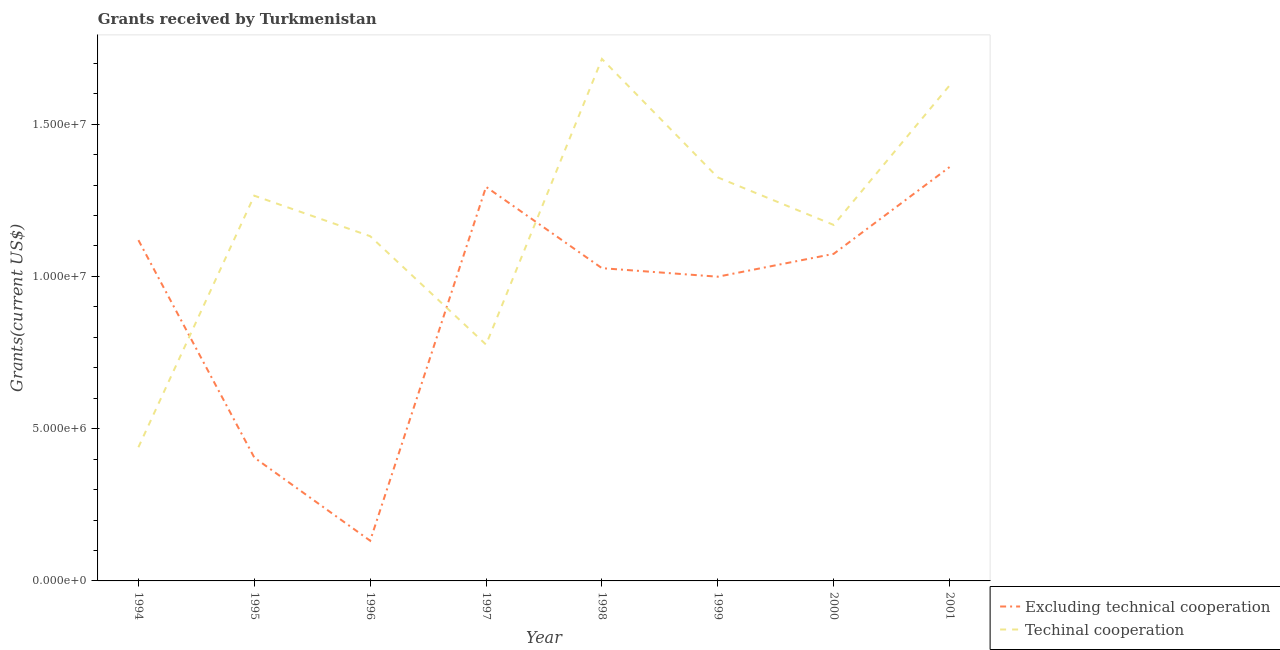How many different coloured lines are there?
Your answer should be very brief. 2. Does the line corresponding to amount of grants received(excluding technical cooperation) intersect with the line corresponding to amount of grants received(including technical cooperation)?
Your response must be concise. Yes. What is the amount of grants received(including technical cooperation) in 2000?
Give a very brief answer. 1.17e+07. Across all years, what is the maximum amount of grants received(including technical cooperation)?
Offer a very short reply. 1.71e+07. Across all years, what is the minimum amount of grants received(including technical cooperation)?
Provide a short and direct response. 4.39e+06. In which year was the amount of grants received(including technical cooperation) maximum?
Provide a short and direct response. 1998. What is the total amount of grants received(including technical cooperation) in the graph?
Keep it short and to the point. 9.45e+07. What is the difference between the amount of grants received(excluding technical cooperation) in 1996 and that in 1999?
Offer a very short reply. -8.67e+06. What is the difference between the amount of grants received(including technical cooperation) in 1997 and the amount of grants received(excluding technical cooperation) in 1995?
Your answer should be very brief. 3.71e+06. What is the average amount of grants received(including technical cooperation) per year?
Give a very brief answer. 1.18e+07. In the year 1998, what is the difference between the amount of grants received(including technical cooperation) and amount of grants received(excluding technical cooperation)?
Your answer should be very brief. 6.87e+06. In how many years, is the amount of grants received(including technical cooperation) greater than 13000000 US$?
Your answer should be compact. 3. What is the ratio of the amount of grants received(excluding technical cooperation) in 1998 to that in 2001?
Your response must be concise. 0.76. Is the difference between the amount of grants received(excluding technical cooperation) in 1994 and 2001 greater than the difference between the amount of grants received(including technical cooperation) in 1994 and 2001?
Your answer should be very brief. Yes. What is the difference between the highest and the second highest amount of grants received(excluding technical cooperation)?
Offer a very short reply. 6.50e+05. What is the difference between the highest and the lowest amount of grants received(excluding technical cooperation)?
Provide a succinct answer. 1.23e+07. Is the amount of grants received(excluding technical cooperation) strictly greater than the amount of grants received(including technical cooperation) over the years?
Ensure brevity in your answer.  No. Is the amount of grants received(including technical cooperation) strictly less than the amount of grants received(excluding technical cooperation) over the years?
Provide a succinct answer. No. Does the graph contain grids?
Offer a terse response. No. How are the legend labels stacked?
Your answer should be very brief. Vertical. What is the title of the graph?
Make the answer very short. Grants received by Turkmenistan. What is the label or title of the Y-axis?
Offer a terse response. Grants(current US$). What is the Grants(current US$) of Excluding technical cooperation in 1994?
Give a very brief answer. 1.12e+07. What is the Grants(current US$) of Techinal cooperation in 1994?
Your answer should be compact. 4.39e+06. What is the Grants(current US$) of Excluding technical cooperation in 1995?
Give a very brief answer. 4.05e+06. What is the Grants(current US$) in Techinal cooperation in 1995?
Ensure brevity in your answer.  1.26e+07. What is the Grants(current US$) in Excluding technical cooperation in 1996?
Your answer should be very brief. 1.32e+06. What is the Grants(current US$) in Techinal cooperation in 1996?
Offer a terse response. 1.13e+07. What is the Grants(current US$) in Excluding technical cooperation in 1997?
Make the answer very short. 1.29e+07. What is the Grants(current US$) in Techinal cooperation in 1997?
Make the answer very short. 7.76e+06. What is the Grants(current US$) of Excluding technical cooperation in 1998?
Your answer should be very brief. 1.03e+07. What is the Grants(current US$) of Techinal cooperation in 1998?
Give a very brief answer. 1.71e+07. What is the Grants(current US$) of Excluding technical cooperation in 1999?
Provide a succinct answer. 9.99e+06. What is the Grants(current US$) in Techinal cooperation in 1999?
Offer a terse response. 1.32e+07. What is the Grants(current US$) in Excluding technical cooperation in 2000?
Keep it short and to the point. 1.07e+07. What is the Grants(current US$) in Techinal cooperation in 2000?
Provide a short and direct response. 1.17e+07. What is the Grants(current US$) in Excluding technical cooperation in 2001?
Your response must be concise. 1.36e+07. What is the Grants(current US$) of Techinal cooperation in 2001?
Offer a terse response. 1.63e+07. Across all years, what is the maximum Grants(current US$) of Excluding technical cooperation?
Make the answer very short. 1.36e+07. Across all years, what is the maximum Grants(current US$) of Techinal cooperation?
Your answer should be compact. 1.71e+07. Across all years, what is the minimum Grants(current US$) of Excluding technical cooperation?
Make the answer very short. 1.32e+06. Across all years, what is the minimum Grants(current US$) in Techinal cooperation?
Provide a short and direct response. 4.39e+06. What is the total Grants(current US$) of Excluding technical cooperation in the graph?
Make the answer very short. 7.41e+07. What is the total Grants(current US$) of Techinal cooperation in the graph?
Your response must be concise. 9.45e+07. What is the difference between the Grants(current US$) of Excluding technical cooperation in 1994 and that in 1995?
Give a very brief answer. 7.14e+06. What is the difference between the Grants(current US$) of Techinal cooperation in 1994 and that in 1995?
Your answer should be very brief. -8.26e+06. What is the difference between the Grants(current US$) in Excluding technical cooperation in 1994 and that in 1996?
Make the answer very short. 9.87e+06. What is the difference between the Grants(current US$) of Techinal cooperation in 1994 and that in 1996?
Your response must be concise. -6.93e+06. What is the difference between the Grants(current US$) in Excluding technical cooperation in 1994 and that in 1997?
Ensure brevity in your answer.  -1.75e+06. What is the difference between the Grants(current US$) in Techinal cooperation in 1994 and that in 1997?
Provide a succinct answer. -3.37e+06. What is the difference between the Grants(current US$) of Excluding technical cooperation in 1994 and that in 1998?
Your answer should be compact. 9.20e+05. What is the difference between the Grants(current US$) of Techinal cooperation in 1994 and that in 1998?
Provide a short and direct response. -1.28e+07. What is the difference between the Grants(current US$) of Excluding technical cooperation in 1994 and that in 1999?
Keep it short and to the point. 1.20e+06. What is the difference between the Grants(current US$) in Techinal cooperation in 1994 and that in 1999?
Keep it short and to the point. -8.86e+06. What is the difference between the Grants(current US$) of Excluding technical cooperation in 1994 and that in 2000?
Make the answer very short. 4.50e+05. What is the difference between the Grants(current US$) in Techinal cooperation in 1994 and that in 2000?
Provide a short and direct response. -7.30e+06. What is the difference between the Grants(current US$) of Excluding technical cooperation in 1994 and that in 2001?
Offer a terse response. -2.40e+06. What is the difference between the Grants(current US$) in Techinal cooperation in 1994 and that in 2001?
Your answer should be very brief. -1.19e+07. What is the difference between the Grants(current US$) in Excluding technical cooperation in 1995 and that in 1996?
Your answer should be very brief. 2.73e+06. What is the difference between the Grants(current US$) in Techinal cooperation in 1995 and that in 1996?
Give a very brief answer. 1.33e+06. What is the difference between the Grants(current US$) in Excluding technical cooperation in 1995 and that in 1997?
Your answer should be compact. -8.89e+06. What is the difference between the Grants(current US$) of Techinal cooperation in 1995 and that in 1997?
Provide a short and direct response. 4.89e+06. What is the difference between the Grants(current US$) in Excluding technical cooperation in 1995 and that in 1998?
Give a very brief answer. -6.22e+06. What is the difference between the Grants(current US$) in Techinal cooperation in 1995 and that in 1998?
Provide a succinct answer. -4.49e+06. What is the difference between the Grants(current US$) in Excluding technical cooperation in 1995 and that in 1999?
Provide a succinct answer. -5.94e+06. What is the difference between the Grants(current US$) in Techinal cooperation in 1995 and that in 1999?
Provide a succinct answer. -6.00e+05. What is the difference between the Grants(current US$) of Excluding technical cooperation in 1995 and that in 2000?
Provide a short and direct response. -6.69e+06. What is the difference between the Grants(current US$) in Techinal cooperation in 1995 and that in 2000?
Ensure brevity in your answer.  9.60e+05. What is the difference between the Grants(current US$) of Excluding technical cooperation in 1995 and that in 2001?
Your answer should be compact. -9.54e+06. What is the difference between the Grants(current US$) of Techinal cooperation in 1995 and that in 2001?
Provide a succinct answer. -3.62e+06. What is the difference between the Grants(current US$) of Excluding technical cooperation in 1996 and that in 1997?
Your response must be concise. -1.16e+07. What is the difference between the Grants(current US$) of Techinal cooperation in 1996 and that in 1997?
Provide a short and direct response. 3.56e+06. What is the difference between the Grants(current US$) in Excluding technical cooperation in 1996 and that in 1998?
Make the answer very short. -8.95e+06. What is the difference between the Grants(current US$) in Techinal cooperation in 1996 and that in 1998?
Offer a terse response. -5.82e+06. What is the difference between the Grants(current US$) of Excluding technical cooperation in 1996 and that in 1999?
Give a very brief answer. -8.67e+06. What is the difference between the Grants(current US$) in Techinal cooperation in 1996 and that in 1999?
Keep it short and to the point. -1.93e+06. What is the difference between the Grants(current US$) in Excluding technical cooperation in 1996 and that in 2000?
Make the answer very short. -9.42e+06. What is the difference between the Grants(current US$) in Techinal cooperation in 1996 and that in 2000?
Keep it short and to the point. -3.70e+05. What is the difference between the Grants(current US$) in Excluding technical cooperation in 1996 and that in 2001?
Ensure brevity in your answer.  -1.23e+07. What is the difference between the Grants(current US$) of Techinal cooperation in 1996 and that in 2001?
Keep it short and to the point. -4.95e+06. What is the difference between the Grants(current US$) of Excluding technical cooperation in 1997 and that in 1998?
Give a very brief answer. 2.67e+06. What is the difference between the Grants(current US$) in Techinal cooperation in 1997 and that in 1998?
Ensure brevity in your answer.  -9.38e+06. What is the difference between the Grants(current US$) of Excluding technical cooperation in 1997 and that in 1999?
Offer a very short reply. 2.95e+06. What is the difference between the Grants(current US$) in Techinal cooperation in 1997 and that in 1999?
Provide a succinct answer. -5.49e+06. What is the difference between the Grants(current US$) of Excluding technical cooperation in 1997 and that in 2000?
Offer a very short reply. 2.20e+06. What is the difference between the Grants(current US$) of Techinal cooperation in 1997 and that in 2000?
Your answer should be very brief. -3.93e+06. What is the difference between the Grants(current US$) of Excluding technical cooperation in 1997 and that in 2001?
Your answer should be compact. -6.50e+05. What is the difference between the Grants(current US$) of Techinal cooperation in 1997 and that in 2001?
Keep it short and to the point. -8.51e+06. What is the difference between the Grants(current US$) in Techinal cooperation in 1998 and that in 1999?
Offer a terse response. 3.89e+06. What is the difference between the Grants(current US$) in Excluding technical cooperation in 1998 and that in 2000?
Your answer should be very brief. -4.70e+05. What is the difference between the Grants(current US$) in Techinal cooperation in 1998 and that in 2000?
Your response must be concise. 5.45e+06. What is the difference between the Grants(current US$) of Excluding technical cooperation in 1998 and that in 2001?
Give a very brief answer. -3.32e+06. What is the difference between the Grants(current US$) in Techinal cooperation in 1998 and that in 2001?
Make the answer very short. 8.70e+05. What is the difference between the Grants(current US$) in Excluding technical cooperation in 1999 and that in 2000?
Keep it short and to the point. -7.50e+05. What is the difference between the Grants(current US$) in Techinal cooperation in 1999 and that in 2000?
Ensure brevity in your answer.  1.56e+06. What is the difference between the Grants(current US$) in Excluding technical cooperation in 1999 and that in 2001?
Your response must be concise. -3.60e+06. What is the difference between the Grants(current US$) of Techinal cooperation in 1999 and that in 2001?
Your answer should be compact. -3.02e+06. What is the difference between the Grants(current US$) in Excluding technical cooperation in 2000 and that in 2001?
Make the answer very short. -2.85e+06. What is the difference between the Grants(current US$) in Techinal cooperation in 2000 and that in 2001?
Offer a terse response. -4.58e+06. What is the difference between the Grants(current US$) of Excluding technical cooperation in 1994 and the Grants(current US$) of Techinal cooperation in 1995?
Provide a short and direct response. -1.46e+06. What is the difference between the Grants(current US$) of Excluding technical cooperation in 1994 and the Grants(current US$) of Techinal cooperation in 1997?
Your answer should be very brief. 3.43e+06. What is the difference between the Grants(current US$) in Excluding technical cooperation in 1994 and the Grants(current US$) in Techinal cooperation in 1998?
Your answer should be compact. -5.95e+06. What is the difference between the Grants(current US$) of Excluding technical cooperation in 1994 and the Grants(current US$) of Techinal cooperation in 1999?
Ensure brevity in your answer.  -2.06e+06. What is the difference between the Grants(current US$) in Excluding technical cooperation in 1994 and the Grants(current US$) in Techinal cooperation in 2000?
Your answer should be compact. -5.00e+05. What is the difference between the Grants(current US$) of Excluding technical cooperation in 1994 and the Grants(current US$) of Techinal cooperation in 2001?
Provide a succinct answer. -5.08e+06. What is the difference between the Grants(current US$) of Excluding technical cooperation in 1995 and the Grants(current US$) of Techinal cooperation in 1996?
Provide a short and direct response. -7.27e+06. What is the difference between the Grants(current US$) of Excluding technical cooperation in 1995 and the Grants(current US$) of Techinal cooperation in 1997?
Offer a terse response. -3.71e+06. What is the difference between the Grants(current US$) of Excluding technical cooperation in 1995 and the Grants(current US$) of Techinal cooperation in 1998?
Offer a terse response. -1.31e+07. What is the difference between the Grants(current US$) of Excluding technical cooperation in 1995 and the Grants(current US$) of Techinal cooperation in 1999?
Ensure brevity in your answer.  -9.20e+06. What is the difference between the Grants(current US$) of Excluding technical cooperation in 1995 and the Grants(current US$) of Techinal cooperation in 2000?
Your answer should be compact. -7.64e+06. What is the difference between the Grants(current US$) in Excluding technical cooperation in 1995 and the Grants(current US$) in Techinal cooperation in 2001?
Provide a short and direct response. -1.22e+07. What is the difference between the Grants(current US$) in Excluding technical cooperation in 1996 and the Grants(current US$) in Techinal cooperation in 1997?
Provide a short and direct response. -6.44e+06. What is the difference between the Grants(current US$) of Excluding technical cooperation in 1996 and the Grants(current US$) of Techinal cooperation in 1998?
Your answer should be compact. -1.58e+07. What is the difference between the Grants(current US$) of Excluding technical cooperation in 1996 and the Grants(current US$) of Techinal cooperation in 1999?
Offer a very short reply. -1.19e+07. What is the difference between the Grants(current US$) of Excluding technical cooperation in 1996 and the Grants(current US$) of Techinal cooperation in 2000?
Offer a terse response. -1.04e+07. What is the difference between the Grants(current US$) of Excluding technical cooperation in 1996 and the Grants(current US$) of Techinal cooperation in 2001?
Provide a succinct answer. -1.50e+07. What is the difference between the Grants(current US$) in Excluding technical cooperation in 1997 and the Grants(current US$) in Techinal cooperation in 1998?
Keep it short and to the point. -4.20e+06. What is the difference between the Grants(current US$) in Excluding technical cooperation in 1997 and the Grants(current US$) in Techinal cooperation in 1999?
Ensure brevity in your answer.  -3.10e+05. What is the difference between the Grants(current US$) in Excluding technical cooperation in 1997 and the Grants(current US$) in Techinal cooperation in 2000?
Keep it short and to the point. 1.25e+06. What is the difference between the Grants(current US$) of Excluding technical cooperation in 1997 and the Grants(current US$) of Techinal cooperation in 2001?
Your response must be concise. -3.33e+06. What is the difference between the Grants(current US$) of Excluding technical cooperation in 1998 and the Grants(current US$) of Techinal cooperation in 1999?
Provide a succinct answer. -2.98e+06. What is the difference between the Grants(current US$) in Excluding technical cooperation in 1998 and the Grants(current US$) in Techinal cooperation in 2000?
Provide a succinct answer. -1.42e+06. What is the difference between the Grants(current US$) in Excluding technical cooperation in 1998 and the Grants(current US$) in Techinal cooperation in 2001?
Ensure brevity in your answer.  -6.00e+06. What is the difference between the Grants(current US$) of Excluding technical cooperation in 1999 and the Grants(current US$) of Techinal cooperation in 2000?
Offer a very short reply. -1.70e+06. What is the difference between the Grants(current US$) of Excluding technical cooperation in 1999 and the Grants(current US$) of Techinal cooperation in 2001?
Make the answer very short. -6.28e+06. What is the difference between the Grants(current US$) in Excluding technical cooperation in 2000 and the Grants(current US$) in Techinal cooperation in 2001?
Make the answer very short. -5.53e+06. What is the average Grants(current US$) in Excluding technical cooperation per year?
Keep it short and to the point. 9.26e+06. What is the average Grants(current US$) in Techinal cooperation per year?
Your response must be concise. 1.18e+07. In the year 1994, what is the difference between the Grants(current US$) in Excluding technical cooperation and Grants(current US$) in Techinal cooperation?
Your answer should be very brief. 6.80e+06. In the year 1995, what is the difference between the Grants(current US$) of Excluding technical cooperation and Grants(current US$) of Techinal cooperation?
Your answer should be very brief. -8.60e+06. In the year 1996, what is the difference between the Grants(current US$) of Excluding technical cooperation and Grants(current US$) of Techinal cooperation?
Your answer should be very brief. -1.00e+07. In the year 1997, what is the difference between the Grants(current US$) in Excluding technical cooperation and Grants(current US$) in Techinal cooperation?
Offer a terse response. 5.18e+06. In the year 1998, what is the difference between the Grants(current US$) of Excluding technical cooperation and Grants(current US$) of Techinal cooperation?
Provide a short and direct response. -6.87e+06. In the year 1999, what is the difference between the Grants(current US$) in Excluding technical cooperation and Grants(current US$) in Techinal cooperation?
Ensure brevity in your answer.  -3.26e+06. In the year 2000, what is the difference between the Grants(current US$) in Excluding technical cooperation and Grants(current US$) in Techinal cooperation?
Ensure brevity in your answer.  -9.50e+05. In the year 2001, what is the difference between the Grants(current US$) in Excluding technical cooperation and Grants(current US$) in Techinal cooperation?
Your response must be concise. -2.68e+06. What is the ratio of the Grants(current US$) in Excluding technical cooperation in 1994 to that in 1995?
Your answer should be very brief. 2.76. What is the ratio of the Grants(current US$) of Techinal cooperation in 1994 to that in 1995?
Offer a very short reply. 0.35. What is the ratio of the Grants(current US$) of Excluding technical cooperation in 1994 to that in 1996?
Your answer should be very brief. 8.48. What is the ratio of the Grants(current US$) of Techinal cooperation in 1994 to that in 1996?
Offer a terse response. 0.39. What is the ratio of the Grants(current US$) in Excluding technical cooperation in 1994 to that in 1997?
Offer a very short reply. 0.86. What is the ratio of the Grants(current US$) in Techinal cooperation in 1994 to that in 1997?
Your answer should be compact. 0.57. What is the ratio of the Grants(current US$) of Excluding technical cooperation in 1994 to that in 1998?
Make the answer very short. 1.09. What is the ratio of the Grants(current US$) of Techinal cooperation in 1994 to that in 1998?
Make the answer very short. 0.26. What is the ratio of the Grants(current US$) in Excluding technical cooperation in 1994 to that in 1999?
Your answer should be very brief. 1.12. What is the ratio of the Grants(current US$) in Techinal cooperation in 1994 to that in 1999?
Your response must be concise. 0.33. What is the ratio of the Grants(current US$) of Excluding technical cooperation in 1994 to that in 2000?
Offer a very short reply. 1.04. What is the ratio of the Grants(current US$) of Techinal cooperation in 1994 to that in 2000?
Keep it short and to the point. 0.38. What is the ratio of the Grants(current US$) of Excluding technical cooperation in 1994 to that in 2001?
Keep it short and to the point. 0.82. What is the ratio of the Grants(current US$) of Techinal cooperation in 1994 to that in 2001?
Make the answer very short. 0.27. What is the ratio of the Grants(current US$) in Excluding technical cooperation in 1995 to that in 1996?
Give a very brief answer. 3.07. What is the ratio of the Grants(current US$) in Techinal cooperation in 1995 to that in 1996?
Your answer should be very brief. 1.12. What is the ratio of the Grants(current US$) in Excluding technical cooperation in 1995 to that in 1997?
Offer a terse response. 0.31. What is the ratio of the Grants(current US$) of Techinal cooperation in 1995 to that in 1997?
Give a very brief answer. 1.63. What is the ratio of the Grants(current US$) of Excluding technical cooperation in 1995 to that in 1998?
Your answer should be compact. 0.39. What is the ratio of the Grants(current US$) in Techinal cooperation in 1995 to that in 1998?
Offer a very short reply. 0.74. What is the ratio of the Grants(current US$) of Excluding technical cooperation in 1995 to that in 1999?
Your answer should be compact. 0.41. What is the ratio of the Grants(current US$) in Techinal cooperation in 1995 to that in 1999?
Ensure brevity in your answer.  0.95. What is the ratio of the Grants(current US$) in Excluding technical cooperation in 1995 to that in 2000?
Give a very brief answer. 0.38. What is the ratio of the Grants(current US$) of Techinal cooperation in 1995 to that in 2000?
Your answer should be very brief. 1.08. What is the ratio of the Grants(current US$) of Excluding technical cooperation in 1995 to that in 2001?
Give a very brief answer. 0.3. What is the ratio of the Grants(current US$) of Techinal cooperation in 1995 to that in 2001?
Make the answer very short. 0.78. What is the ratio of the Grants(current US$) in Excluding technical cooperation in 1996 to that in 1997?
Ensure brevity in your answer.  0.1. What is the ratio of the Grants(current US$) in Techinal cooperation in 1996 to that in 1997?
Ensure brevity in your answer.  1.46. What is the ratio of the Grants(current US$) in Excluding technical cooperation in 1996 to that in 1998?
Give a very brief answer. 0.13. What is the ratio of the Grants(current US$) in Techinal cooperation in 1996 to that in 1998?
Offer a very short reply. 0.66. What is the ratio of the Grants(current US$) in Excluding technical cooperation in 1996 to that in 1999?
Make the answer very short. 0.13. What is the ratio of the Grants(current US$) of Techinal cooperation in 1996 to that in 1999?
Keep it short and to the point. 0.85. What is the ratio of the Grants(current US$) of Excluding technical cooperation in 1996 to that in 2000?
Ensure brevity in your answer.  0.12. What is the ratio of the Grants(current US$) of Techinal cooperation in 1996 to that in 2000?
Your answer should be compact. 0.97. What is the ratio of the Grants(current US$) in Excluding technical cooperation in 1996 to that in 2001?
Your answer should be compact. 0.1. What is the ratio of the Grants(current US$) in Techinal cooperation in 1996 to that in 2001?
Offer a terse response. 0.7. What is the ratio of the Grants(current US$) in Excluding technical cooperation in 1997 to that in 1998?
Provide a short and direct response. 1.26. What is the ratio of the Grants(current US$) in Techinal cooperation in 1997 to that in 1998?
Offer a very short reply. 0.45. What is the ratio of the Grants(current US$) in Excluding technical cooperation in 1997 to that in 1999?
Keep it short and to the point. 1.3. What is the ratio of the Grants(current US$) in Techinal cooperation in 1997 to that in 1999?
Offer a very short reply. 0.59. What is the ratio of the Grants(current US$) of Excluding technical cooperation in 1997 to that in 2000?
Keep it short and to the point. 1.2. What is the ratio of the Grants(current US$) in Techinal cooperation in 1997 to that in 2000?
Ensure brevity in your answer.  0.66. What is the ratio of the Grants(current US$) of Excluding technical cooperation in 1997 to that in 2001?
Your answer should be very brief. 0.95. What is the ratio of the Grants(current US$) of Techinal cooperation in 1997 to that in 2001?
Provide a succinct answer. 0.48. What is the ratio of the Grants(current US$) in Excluding technical cooperation in 1998 to that in 1999?
Keep it short and to the point. 1.03. What is the ratio of the Grants(current US$) in Techinal cooperation in 1998 to that in 1999?
Provide a succinct answer. 1.29. What is the ratio of the Grants(current US$) in Excluding technical cooperation in 1998 to that in 2000?
Your response must be concise. 0.96. What is the ratio of the Grants(current US$) of Techinal cooperation in 1998 to that in 2000?
Keep it short and to the point. 1.47. What is the ratio of the Grants(current US$) in Excluding technical cooperation in 1998 to that in 2001?
Give a very brief answer. 0.76. What is the ratio of the Grants(current US$) in Techinal cooperation in 1998 to that in 2001?
Keep it short and to the point. 1.05. What is the ratio of the Grants(current US$) of Excluding technical cooperation in 1999 to that in 2000?
Offer a terse response. 0.93. What is the ratio of the Grants(current US$) in Techinal cooperation in 1999 to that in 2000?
Make the answer very short. 1.13. What is the ratio of the Grants(current US$) in Excluding technical cooperation in 1999 to that in 2001?
Provide a succinct answer. 0.74. What is the ratio of the Grants(current US$) in Techinal cooperation in 1999 to that in 2001?
Make the answer very short. 0.81. What is the ratio of the Grants(current US$) of Excluding technical cooperation in 2000 to that in 2001?
Offer a terse response. 0.79. What is the ratio of the Grants(current US$) in Techinal cooperation in 2000 to that in 2001?
Your answer should be compact. 0.72. What is the difference between the highest and the second highest Grants(current US$) of Excluding technical cooperation?
Provide a succinct answer. 6.50e+05. What is the difference between the highest and the second highest Grants(current US$) of Techinal cooperation?
Offer a very short reply. 8.70e+05. What is the difference between the highest and the lowest Grants(current US$) of Excluding technical cooperation?
Provide a succinct answer. 1.23e+07. What is the difference between the highest and the lowest Grants(current US$) of Techinal cooperation?
Provide a short and direct response. 1.28e+07. 